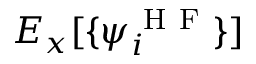<formula> <loc_0><loc_0><loc_500><loc_500>E _ { x } [ \{ \psi _ { i } ^ { H F } \} ]</formula> 